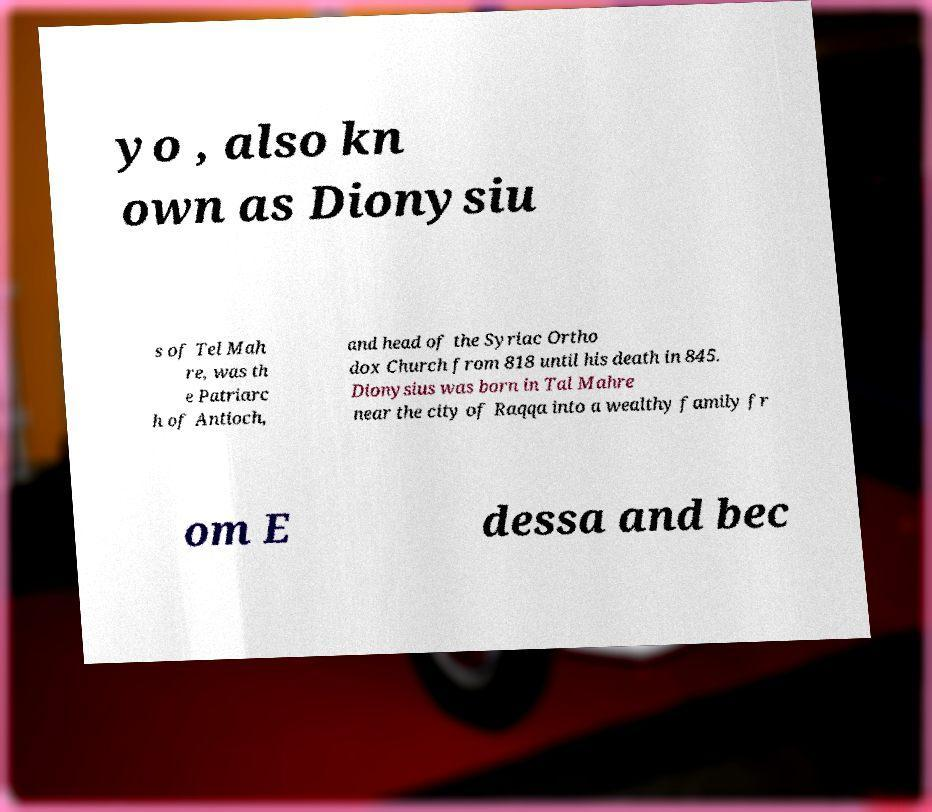There's text embedded in this image that I need extracted. Can you transcribe it verbatim? yo , also kn own as Dionysiu s of Tel Mah re, was th e Patriarc h of Antioch, and head of the Syriac Ortho dox Church from 818 until his death in 845. Dionysius was born in Tal Mahre near the city of Raqqa into a wealthy family fr om E dessa and bec 